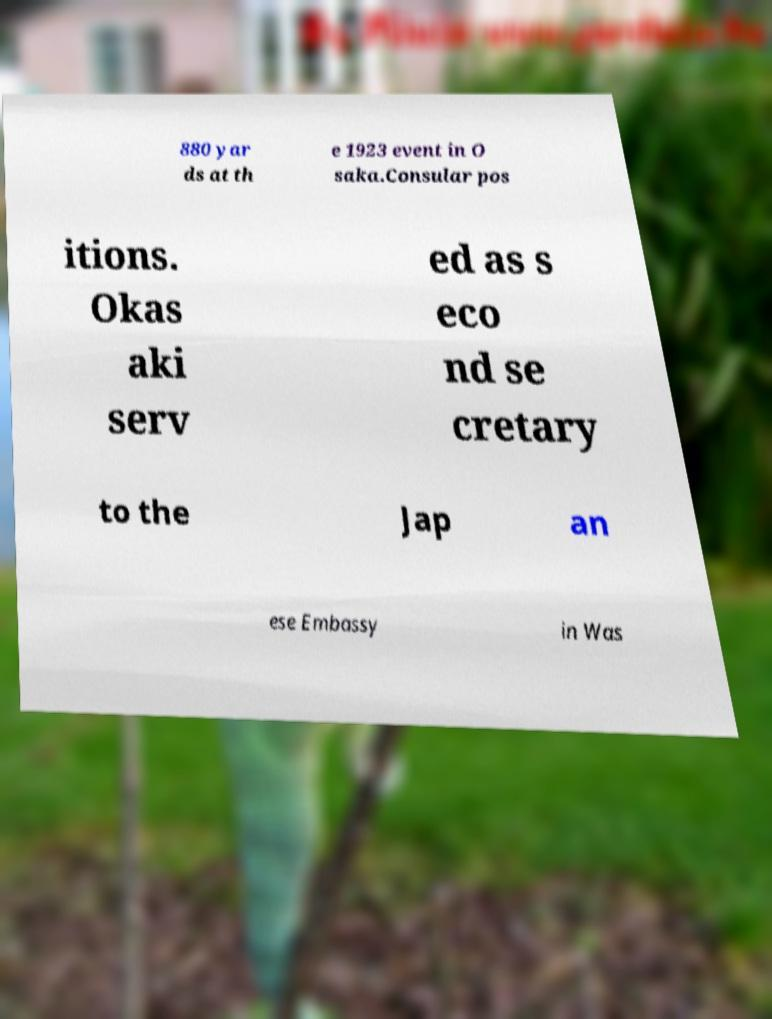There's text embedded in this image that I need extracted. Can you transcribe it verbatim? 880 yar ds at th e 1923 event in O saka.Consular pos itions. Okas aki serv ed as s eco nd se cretary to the Jap an ese Embassy in Was 